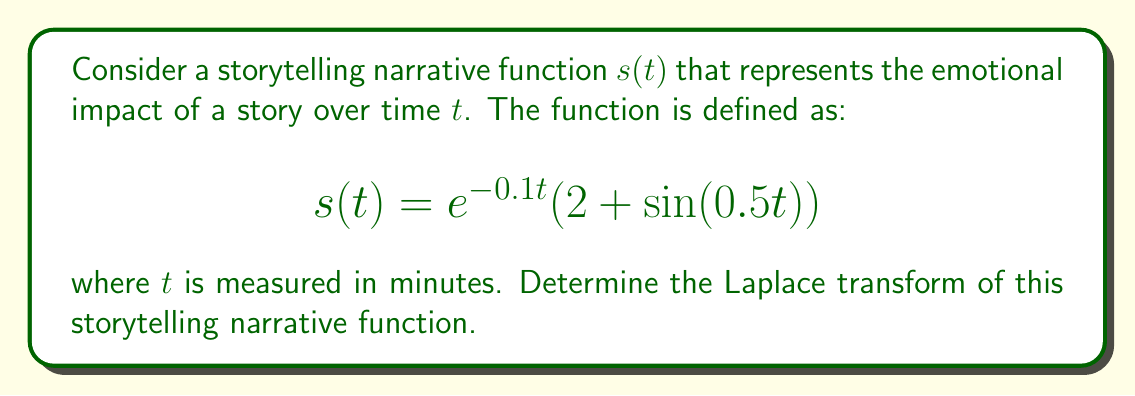Can you solve this math problem? To find the Laplace transform of the given function, we'll follow these steps:

1) The Laplace transform is defined as:

   $$\mathcal{L}\{f(t)\} = F(s) = \int_0^{\infty} e^{-st}f(t)dt$$

2) Our function is:

   $$s(t) = e^{-0.1t}(2 + \sin(0.5t))$$

3) We can rewrite this as:

   $$s(t) = 2e^{-0.1t} + e^{-0.1t}\sin(0.5t)$$

4) The Laplace transform is linear, so we can transform each term separately:

   $$\mathcal{L}\{s(t)\} = 2\mathcal{L}\{e^{-0.1t}\} + \mathcal{L}\{e^{-0.1t}\sin(0.5t)\}$$

5) For the first term, we know that:

   $$\mathcal{L}\{e^{at}\} = \frac{1}{s-a}$$

   So, $$\mathcal{L}\{e^{-0.1t}\} = \frac{1}{s+0.1}$$

6) For the second term, we can use the following property:

   $$\mathcal{L}\{e^{at}\sin(bt)\} = \frac{b}{(s-a)^2 + b^2}$$

   Here, $a = -0.1$ and $b = 0.5$

7) Applying this:

   $$\mathcal{L}\{e^{-0.1t}\sin(0.5t)\} = \frac{0.5}{(s+0.1)^2 + 0.5^2} = \frac{0.5}{(s+0.1)^2 + 0.25}$$

8) Combining the results:

   $$\mathcal{L}\{s(t)\} = \frac{2}{s+0.1} + \frac{0.5}{(s+0.1)^2 + 0.25}$$

This is the Laplace transform of our storytelling narrative function.
Answer: $$\mathcal{L}\{s(t)\} = \frac{2}{s+0.1} + \frac{0.5}{(s+0.1)^2 + 0.25}$$ 